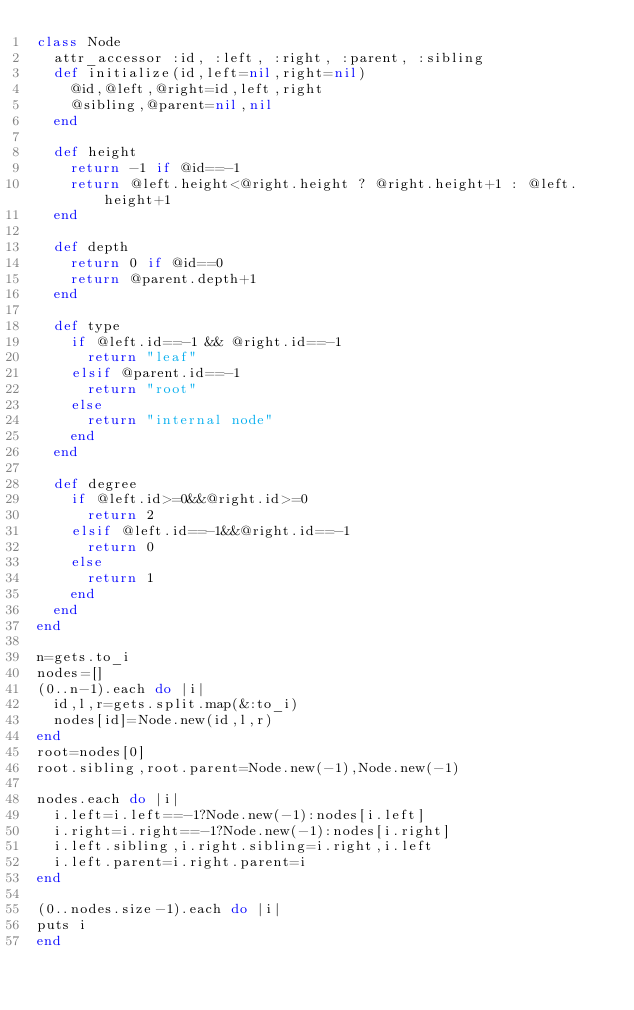<code> <loc_0><loc_0><loc_500><loc_500><_Ruby_>class Node
  attr_accessor :id, :left, :right, :parent, :sibling
  def initialize(id,left=nil,right=nil)
    @id,@left,@right=id,left,right
    @sibling,@parent=nil,nil
  end

  def height
    return -1 if @id==-1
    return @left.height<@right.height ? @right.height+1 : @left.height+1
  end

  def depth
    return 0 if @id==0
    return @parent.depth+1
  end

  def type
    if @left.id==-1 && @right.id==-1
      return "leaf"
    elsif @parent.id==-1
      return "root"
    else
      return "internal node"
    end
  end

  def degree
    if @left.id>=0&&@right.id>=0
      return 2
    elsif @left.id==-1&&@right.id==-1
      return 0
    else
      return 1
    end
  end
end

n=gets.to_i
nodes=[]
(0..n-1).each do |i|
  id,l,r=gets.split.map(&:to_i)
  nodes[id]=Node.new(id,l,r)
end
root=nodes[0]
root.sibling,root.parent=Node.new(-1),Node.new(-1)

nodes.each do |i|
  i.left=i.left==-1?Node.new(-1):nodes[i.left]
  i.right=i.right==-1?Node.new(-1):nodes[i.right]
  i.left.sibling,i.right.sibling=i.right,i.left
  i.left.parent=i.right.parent=i
end

(0..nodes.size-1).each do |i|
puts i
end</code> 